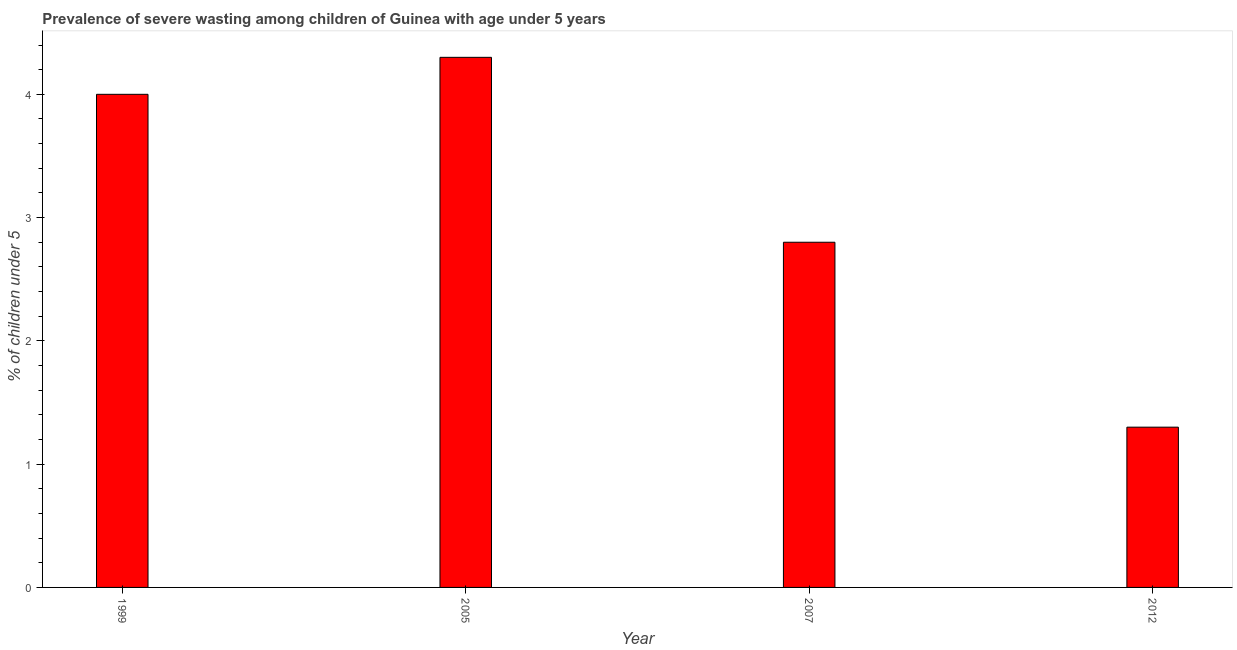Does the graph contain grids?
Your response must be concise. No. What is the title of the graph?
Give a very brief answer. Prevalence of severe wasting among children of Guinea with age under 5 years. What is the label or title of the Y-axis?
Provide a short and direct response.  % of children under 5. What is the prevalence of severe wasting in 2007?
Ensure brevity in your answer.  2.8. Across all years, what is the maximum prevalence of severe wasting?
Keep it short and to the point. 4.3. Across all years, what is the minimum prevalence of severe wasting?
Provide a succinct answer. 1.3. In which year was the prevalence of severe wasting minimum?
Your answer should be compact. 2012. What is the sum of the prevalence of severe wasting?
Provide a short and direct response. 12.4. What is the average prevalence of severe wasting per year?
Your answer should be very brief. 3.1. What is the median prevalence of severe wasting?
Provide a short and direct response. 3.4. In how many years, is the prevalence of severe wasting greater than 2.2 %?
Make the answer very short. 3. Do a majority of the years between 2007 and 2012 (inclusive) have prevalence of severe wasting greater than 2.4 %?
Your answer should be compact. No. What is the ratio of the prevalence of severe wasting in 1999 to that in 2012?
Ensure brevity in your answer.  3.08. Is the difference between the prevalence of severe wasting in 1999 and 2005 greater than the difference between any two years?
Keep it short and to the point. No. What is the difference between the highest and the lowest prevalence of severe wasting?
Your answer should be very brief. 3. In how many years, is the prevalence of severe wasting greater than the average prevalence of severe wasting taken over all years?
Make the answer very short. 2. How many bars are there?
Ensure brevity in your answer.  4. Are all the bars in the graph horizontal?
Your answer should be very brief. No. What is the difference between two consecutive major ticks on the Y-axis?
Your answer should be very brief. 1. Are the values on the major ticks of Y-axis written in scientific E-notation?
Provide a succinct answer. No. What is the  % of children under 5 of 2005?
Your answer should be compact. 4.3. What is the  % of children under 5 of 2007?
Make the answer very short. 2.8. What is the  % of children under 5 of 2012?
Your answer should be very brief. 1.3. What is the difference between the  % of children under 5 in 1999 and 2005?
Offer a very short reply. -0.3. What is the difference between the  % of children under 5 in 1999 and 2007?
Provide a short and direct response. 1.2. What is the difference between the  % of children under 5 in 1999 and 2012?
Ensure brevity in your answer.  2.7. What is the difference between the  % of children under 5 in 2005 and 2007?
Provide a short and direct response. 1.5. What is the difference between the  % of children under 5 in 2005 and 2012?
Provide a short and direct response. 3. What is the ratio of the  % of children under 5 in 1999 to that in 2007?
Make the answer very short. 1.43. What is the ratio of the  % of children under 5 in 1999 to that in 2012?
Make the answer very short. 3.08. What is the ratio of the  % of children under 5 in 2005 to that in 2007?
Keep it short and to the point. 1.54. What is the ratio of the  % of children under 5 in 2005 to that in 2012?
Your answer should be very brief. 3.31. What is the ratio of the  % of children under 5 in 2007 to that in 2012?
Your answer should be very brief. 2.15. 